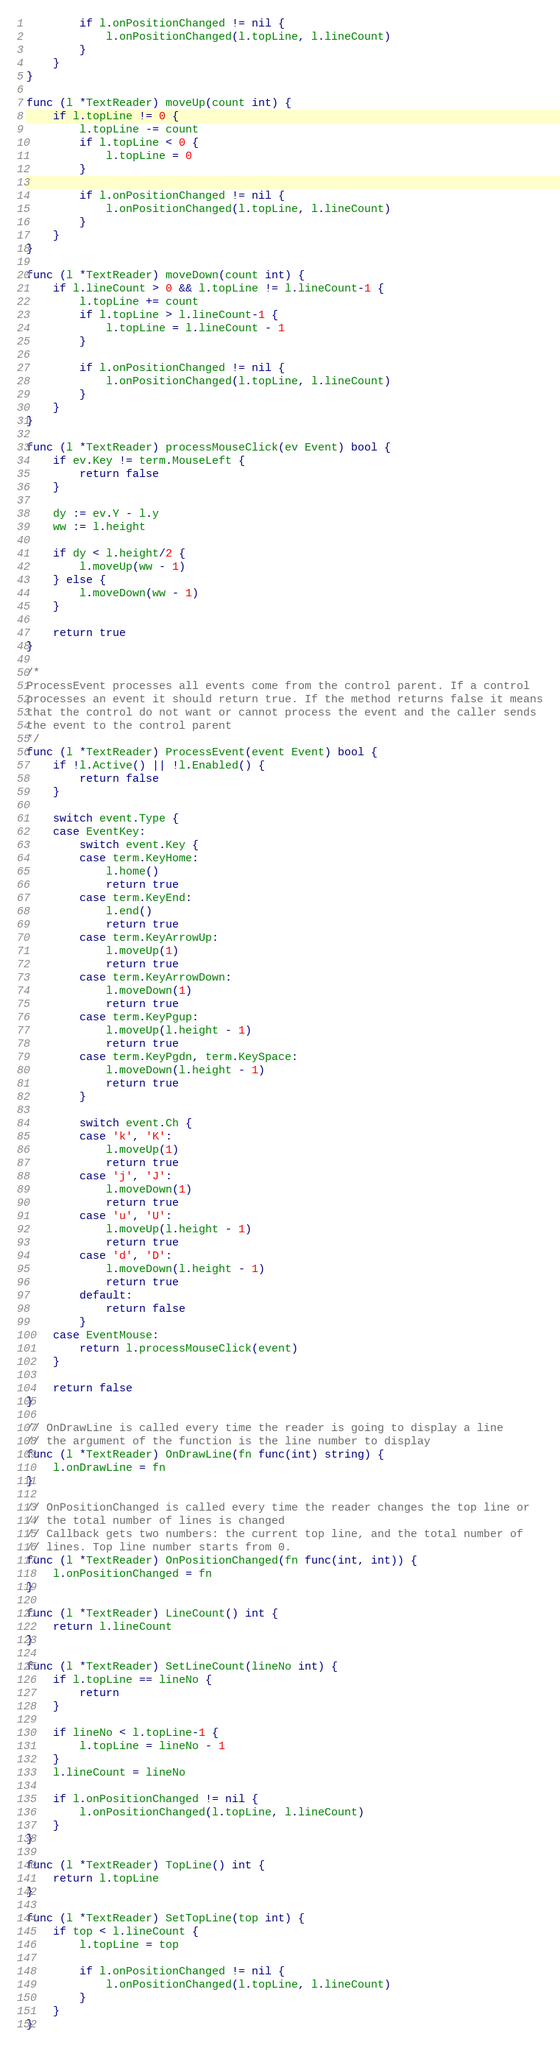<code> <loc_0><loc_0><loc_500><loc_500><_Go_>
		if l.onPositionChanged != nil {
			l.onPositionChanged(l.topLine, l.lineCount)
		}
	}
}

func (l *TextReader) moveUp(count int) {
	if l.topLine != 0 {
		l.topLine -= count
		if l.topLine < 0 {
			l.topLine = 0
		}

		if l.onPositionChanged != nil {
			l.onPositionChanged(l.topLine, l.lineCount)
		}
	}
}

func (l *TextReader) moveDown(count int) {
	if l.lineCount > 0 && l.topLine != l.lineCount-1 {
		l.topLine += count
		if l.topLine > l.lineCount-1 {
			l.topLine = l.lineCount - 1
		}

		if l.onPositionChanged != nil {
			l.onPositionChanged(l.topLine, l.lineCount)
		}
	}
}

func (l *TextReader) processMouseClick(ev Event) bool {
	if ev.Key != term.MouseLeft {
		return false
	}

	dy := ev.Y - l.y
	ww := l.height

	if dy < l.height/2 {
		l.moveUp(ww - 1)
	} else {
		l.moveDown(ww - 1)
	}

	return true
}

/*
ProcessEvent processes all events come from the control parent. If a control
processes an event it should return true. If the method returns false it means
that the control do not want or cannot process the event and the caller sends
the event to the control parent
*/
func (l *TextReader) ProcessEvent(event Event) bool {
	if !l.Active() || !l.Enabled() {
		return false
	}

	switch event.Type {
	case EventKey:
		switch event.Key {
		case term.KeyHome:
			l.home()
			return true
		case term.KeyEnd:
			l.end()
			return true
		case term.KeyArrowUp:
			l.moveUp(1)
			return true
		case term.KeyArrowDown:
			l.moveDown(1)
			return true
		case term.KeyPgup:
			l.moveUp(l.height - 1)
			return true
		case term.KeyPgdn, term.KeySpace:
			l.moveDown(l.height - 1)
			return true
		}

		switch event.Ch {
		case 'k', 'K':
			l.moveUp(1)
			return true
		case 'j', 'J':
			l.moveDown(1)
			return true
		case 'u', 'U':
			l.moveUp(l.height - 1)
			return true
		case 'd', 'D':
			l.moveDown(l.height - 1)
			return true
		default:
			return false
		}
	case EventMouse:
		return l.processMouseClick(event)
	}

	return false
}

// OnDrawLine is called every time the reader is going to display a line
// the argument of the function is the line number to display
func (l *TextReader) OnDrawLine(fn func(int) string) {
	l.onDrawLine = fn
}

// OnPositionChanged is called every time the reader changes the top line or
// the total number of lines is changed
// Callback gets two numbers: the current top line, and the total number of
// lines. Top line number starts from 0.
func (l *TextReader) OnPositionChanged(fn func(int, int)) {
	l.onPositionChanged = fn
}

func (l *TextReader) LineCount() int {
	return l.lineCount
}

func (l *TextReader) SetLineCount(lineNo int) {
	if l.topLine == lineNo {
		return
	}

	if lineNo < l.topLine-1 {
		l.topLine = lineNo - 1
	}
	l.lineCount = lineNo

	if l.onPositionChanged != nil {
		l.onPositionChanged(l.topLine, l.lineCount)
	}
}

func (l *TextReader) TopLine() int {
	return l.topLine
}

func (l *TextReader) SetTopLine(top int) {
	if top < l.lineCount {
        l.topLine = top

        if l.onPositionChanged != nil {
            l.onPositionChanged(l.topLine, l.lineCount)
        }
    }
}
</code> 